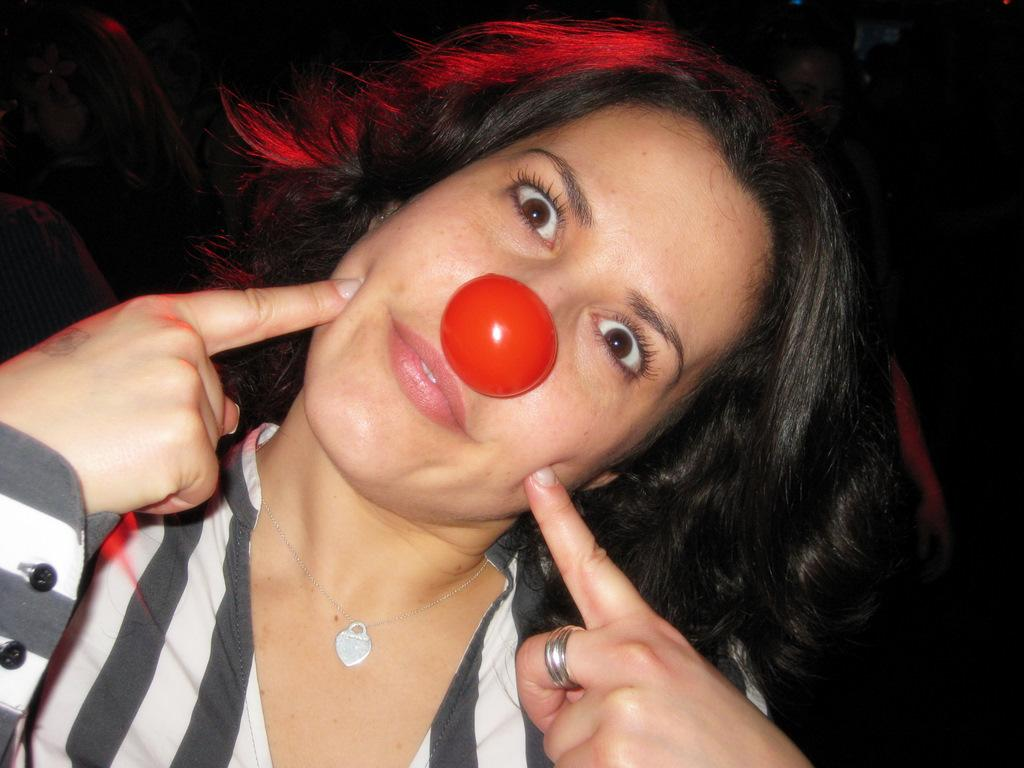Who is the main subject in the image? There is a woman in the image. Where is the woman positioned in the image? The woman is in the front of the image. What is the woman wearing that is unusual? The woman is wearing a clown nose. What is the color of the background in the image? The background of the image is dark. How many oranges are being used to create the chain in the image? There are no oranges or chains present in the image. What type of match is being used by the woman in the image? There is no match visible in the image. 